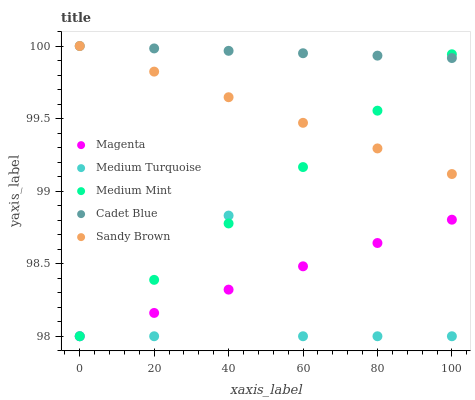Does Medium Turquoise have the minimum area under the curve?
Answer yes or no. Yes. Does Cadet Blue have the maximum area under the curve?
Answer yes or no. Yes. Does Magenta have the minimum area under the curve?
Answer yes or no. No. Does Magenta have the maximum area under the curve?
Answer yes or no. No. Is Sandy Brown the smoothest?
Answer yes or no. Yes. Is Medium Turquoise the roughest?
Answer yes or no. Yes. Is Magenta the smoothest?
Answer yes or no. No. Is Magenta the roughest?
Answer yes or no. No. Does Medium Mint have the lowest value?
Answer yes or no. Yes. Does Cadet Blue have the lowest value?
Answer yes or no. No. Does Sandy Brown have the highest value?
Answer yes or no. Yes. Does Magenta have the highest value?
Answer yes or no. No. Is Magenta less than Cadet Blue?
Answer yes or no. Yes. Is Cadet Blue greater than Magenta?
Answer yes or no. Yes. Does Magenta intersect Medium Turquoise?
Answer yes or no. Yes. Is Magenta less than Medium Turquoise?
Answer yes or no. No. Is Magenta greater than Medium Turquoise?
Answer yes or no. No. Does Magenta intersect Cadet Blue?
Answer yes or no. No. 